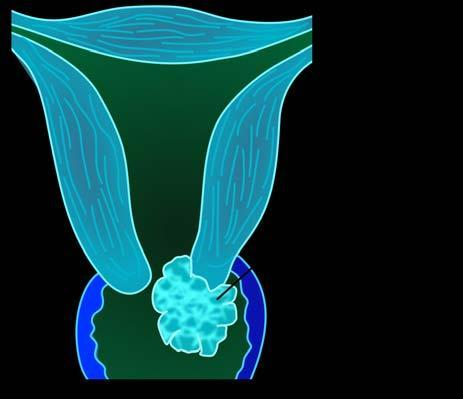does bilayer lipid membrane show replacement of the cervix by irregular greywhite friable growth extending into cervical canal as well as distally into attached vaginal cuff?
Answer the question using a single word or phrase. No 